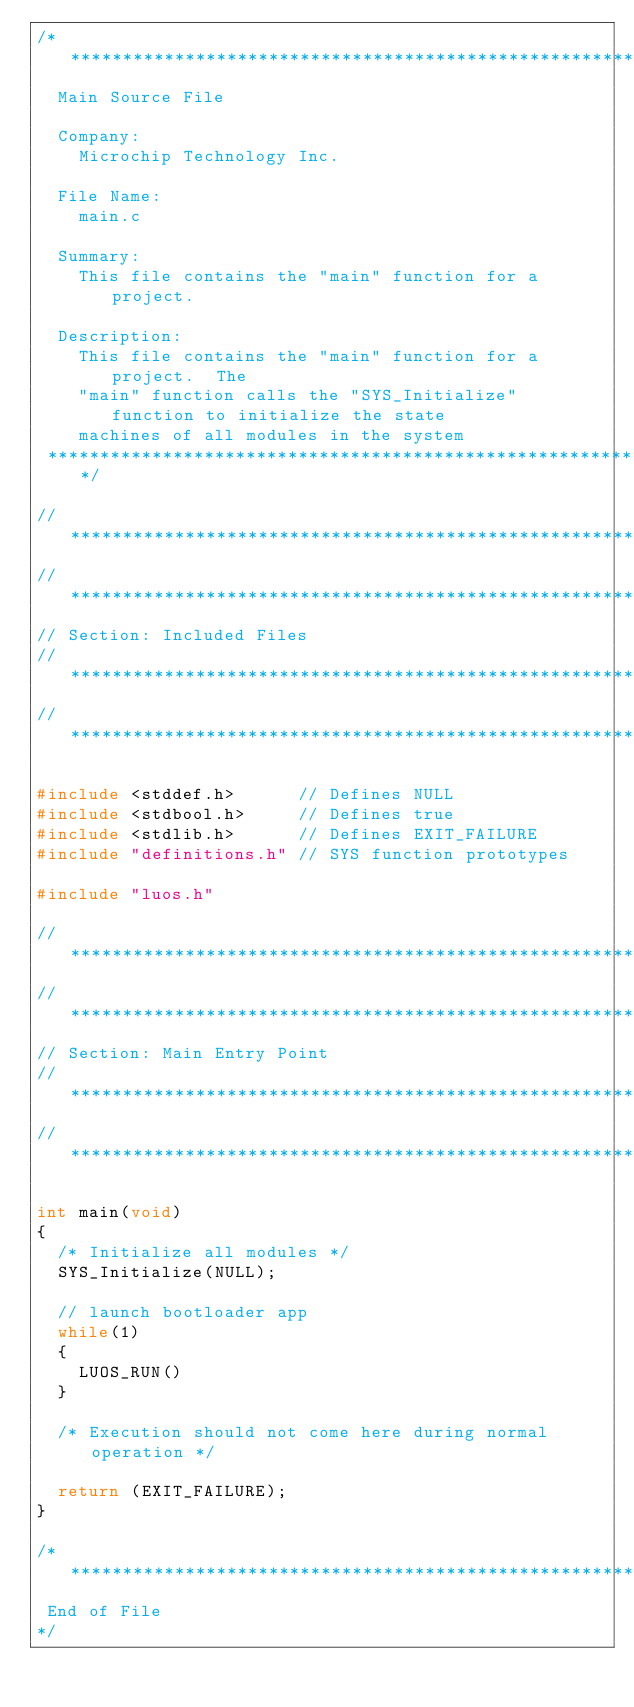<code> <loc_0><loc_0><loc_500><loc_500><_C_>/*******************************************************************************
  Main Source File

  Company:
    Microchip Technology Inc.

  File Name:
    main.c

  Summary:
    This file contains the "main" function for a project.

  Description:
    This file contains the "main" function for a project.  The
    "main" function calls the "SYS_Initialize" function to initialize the state
    machines of all modules in the system
 *******************************************************************************/

// *****************************************************************************
// *****************************************************************************
// Section: Included Files
// *****************************************************************************
// *****************************************************************************

#include <stddef.h>      // Defines NULL
#include <stdbool.h>     // Defines true
#include <stdlib.h>      // Defines EXIT_FAILURE
#include "definitions.h" // SYS function prototypes

#include "luos.h"

// *****************************************************************************
// *****************************************************************************
// Section: Main Entry Point
// *****************************************************************************
// *****************************************************************************

int main(void)
{
  /* Initialize all modules */
  SYS_Initialize(NULL);

  // launch bootloader app
  while(1)
  {
    LUOS_RUN()
  }

  /* Execution should not come here during normal operation */

  return (EXIT_FAILURE);
}

/*******************************************************************************
 End of File
*/
</code> 